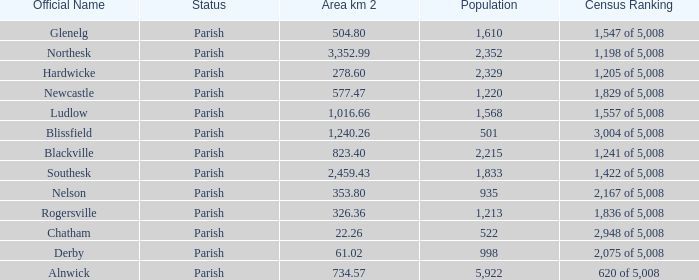Can you tell me the sum of Area km 2 that has the Official Name of glenelg? 504.8. 